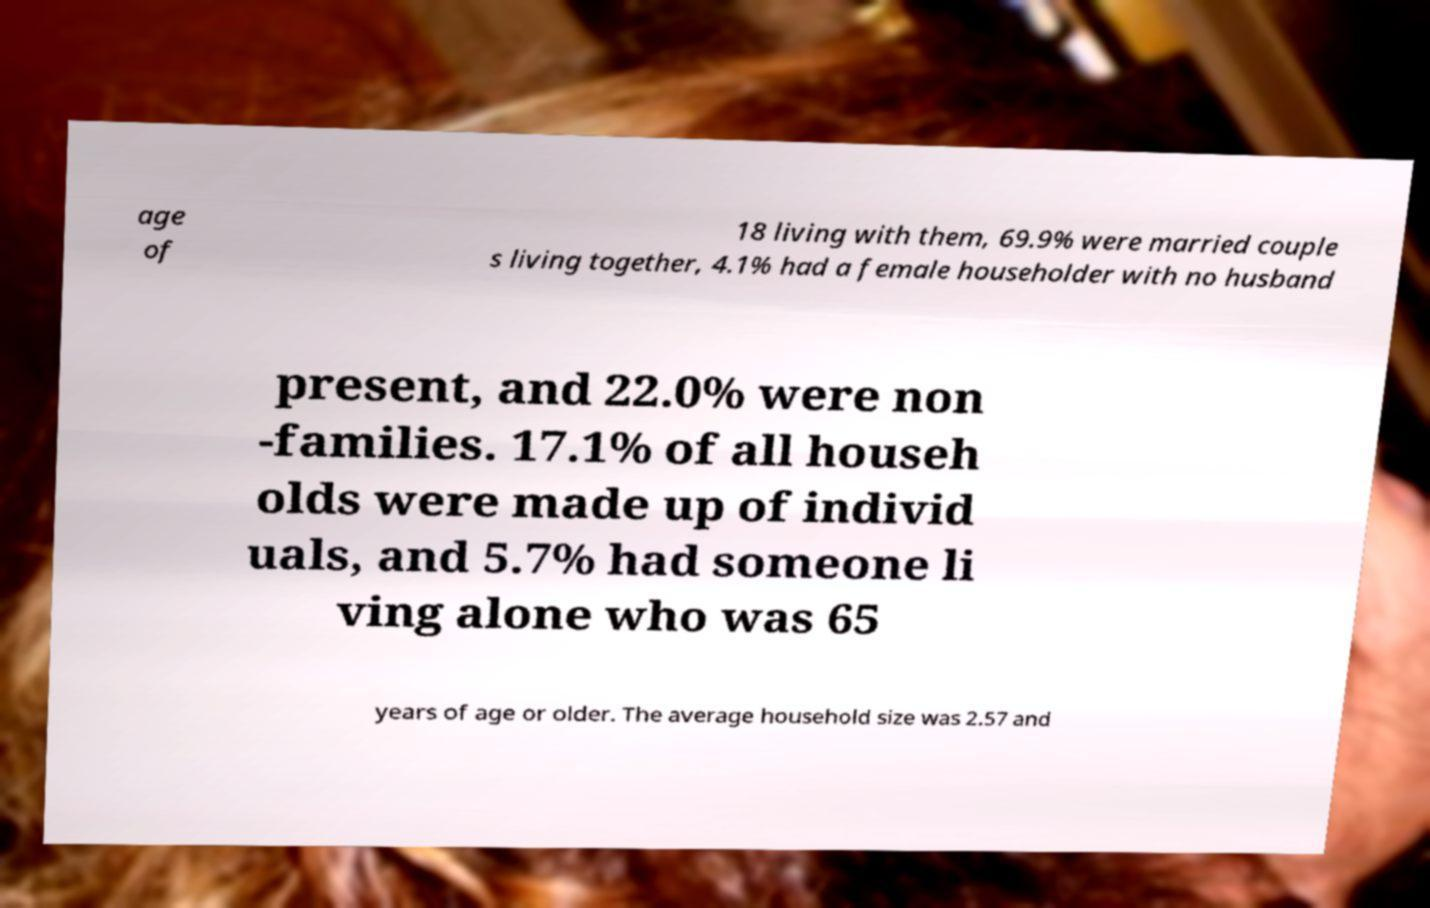Could you extract and type out the text from this image? age of 18 living with them, 69.9% were married couple s living together, 4.1% had a female householder with no husband present, and 22.0% were non -families. 17.1% of all househ olds were made up of individ uals, and 5.7% had someone li ving alone who was 65 years of age or older. The average household size was 2.57 and 